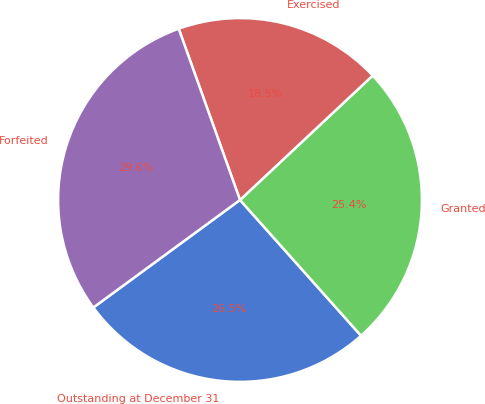Convert chart. <chart><loc_0><loc_0><loc_500><loc_500><pie_chart><fcel>Outstanding at December 31<fcel>Granted<fcel>Exercised<fcel>Forfeited<nl><fcel>26.52%<fcel>25.4%<fcel>18.48%<fcel>29.6%<nl></chart> 